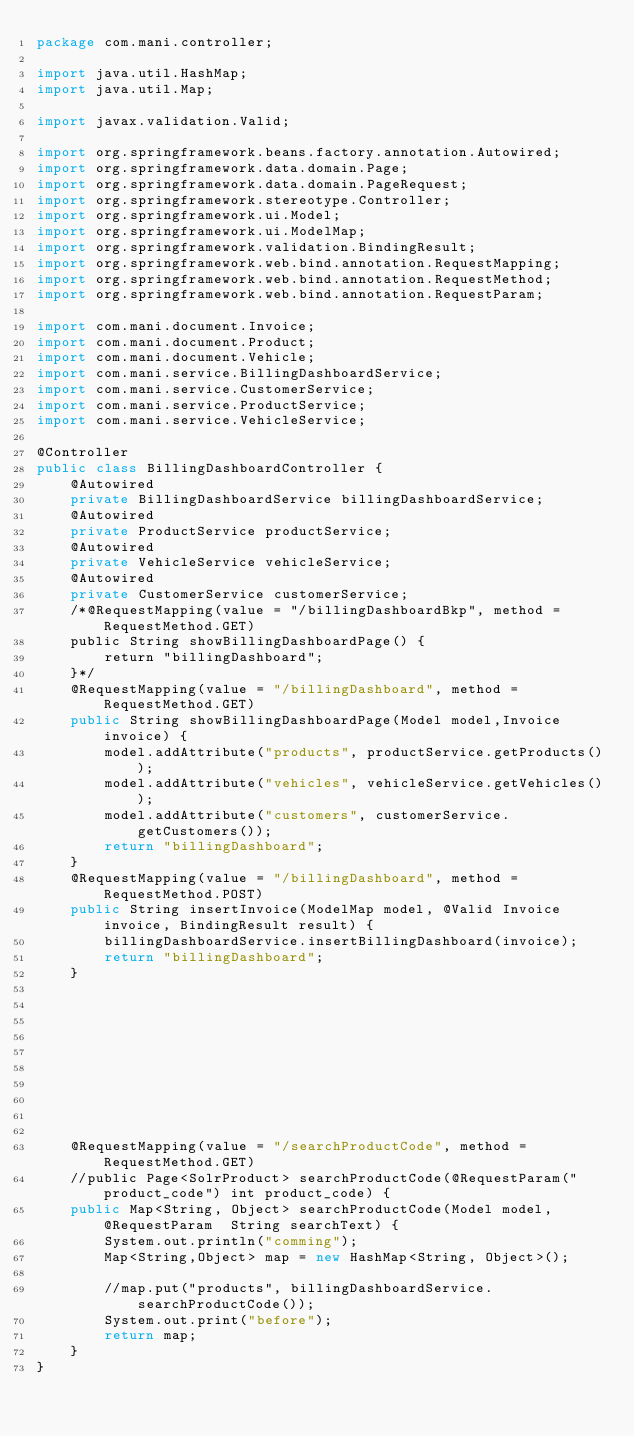Convert code to text. <code><loc_0><loc_0><loc_500><loc_500><_Java_>package com.mani.controller;

import java.util.HashMap;
import java.util.Map;

import javax.validation.Valid;

import org.springframework.beans.factory.annotation.Autowired;
import org.springframework.data.domain.Page;
import org.springframework.data.domain.PageRequest;
import org.springframework.stereotype.Controller;
import org.springframework.ui.Model;
import org.springframework.ui.ModelMap;
import org.springframework.validation.BindingResult;
import org.springframework.web.bind.annotation.RequestMapping;
import org.springframework.web.bind.annotation.RequestMethod;
import org.springframework.web.bind.annotation.RequestParam;

import com.mani.document.Invoice;
import com.mani.document.Product;
import com.mani.document.Vehicle;
import com.mani.service.BillingDashboardService;
import com.mani.service.CustomerService;
import com.mani.service.ProductService;
import com.mani.service.VehicleService;

@Controller
public class BillingDashboardController {
	@Autowired
	private BillingDashboardService billingDashboardService;
	@Autowired
	private ProductService productService;
	@Autowired
	private VehicleService vehicleService;
	@Autowired
	private CustomerService customerService;
	/*@RequestMapping(value = "/billingDashboardBkp", method = RequestMethod.GET)
	public String showBillingDashboardPage() {
		return "billingDashboard";
	}*/
	@RequestMapping(value = "/billingDashboard", method = RequestMethod.GET)
	public String showBillingDashboardPage(Model model,Invoice invoice) {
		model.addAttribute("products", productService.getProducts());
		model.addAttribute("vehicles", vehicleService.getVehicles());
		model.addAttribute("customers", customerService.getCustomers());
		return "billingDashboard";
	}
	@RequestMapping(value = "/billingDashboard", method = RequestMethod.POST)
	public String insertInvoice(ModelMap model, @Valid Invoice invoice, BindingResult result) {
		billingDashboardService.insertBillingDashboard(invoice);
		return "billingDashboard";
	}
	
	
	
	
	
	
	
	
	
	
	@RequestMapping(value = "/searchProductCode", method = RequestMethod.GET)
	//public Page<SolrProduct> searchProductCode(@RequestParam("product_code") int product_code) {
	public Map<String, Object> searchProductCode(Model model, @RequestParam  String searchText) {
		System.out.println("comming");
		Map<String,Object> map = new HashMap<String, Object>();
	 
		//map.put("products", billingDashboardService.searchProductCode());
		System.out.print("before");
		return map;
	}
}
</code> 